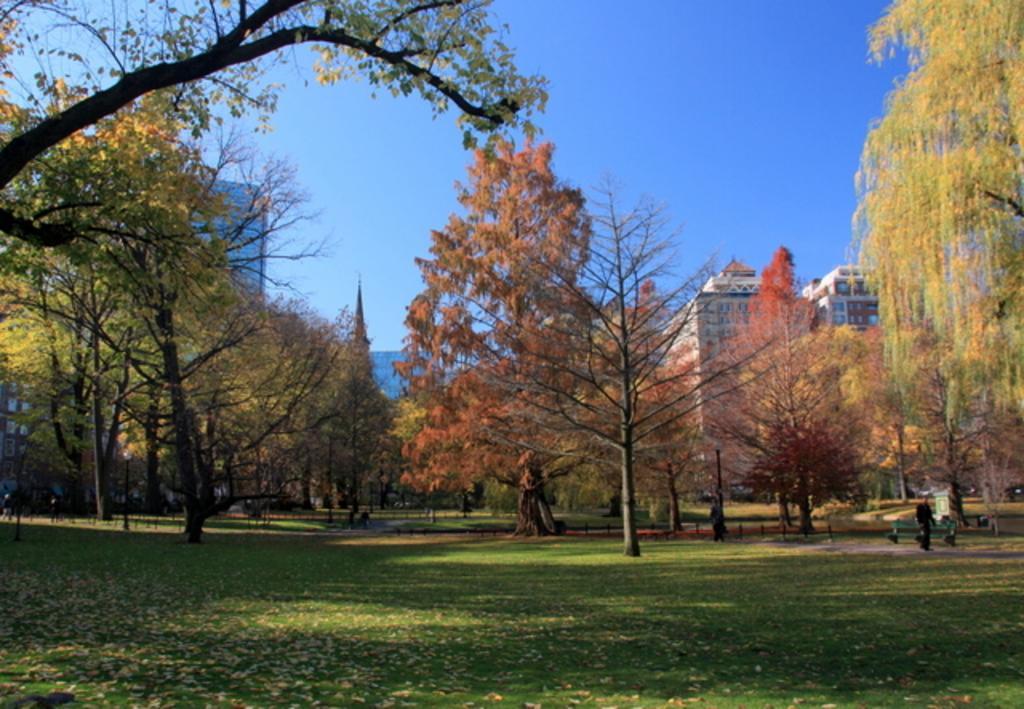Please provide a concise description of this image. In this image I can see the grass, a person standing, a bench and few trees. In the background I can see few other persons, few buildings and the sky. 